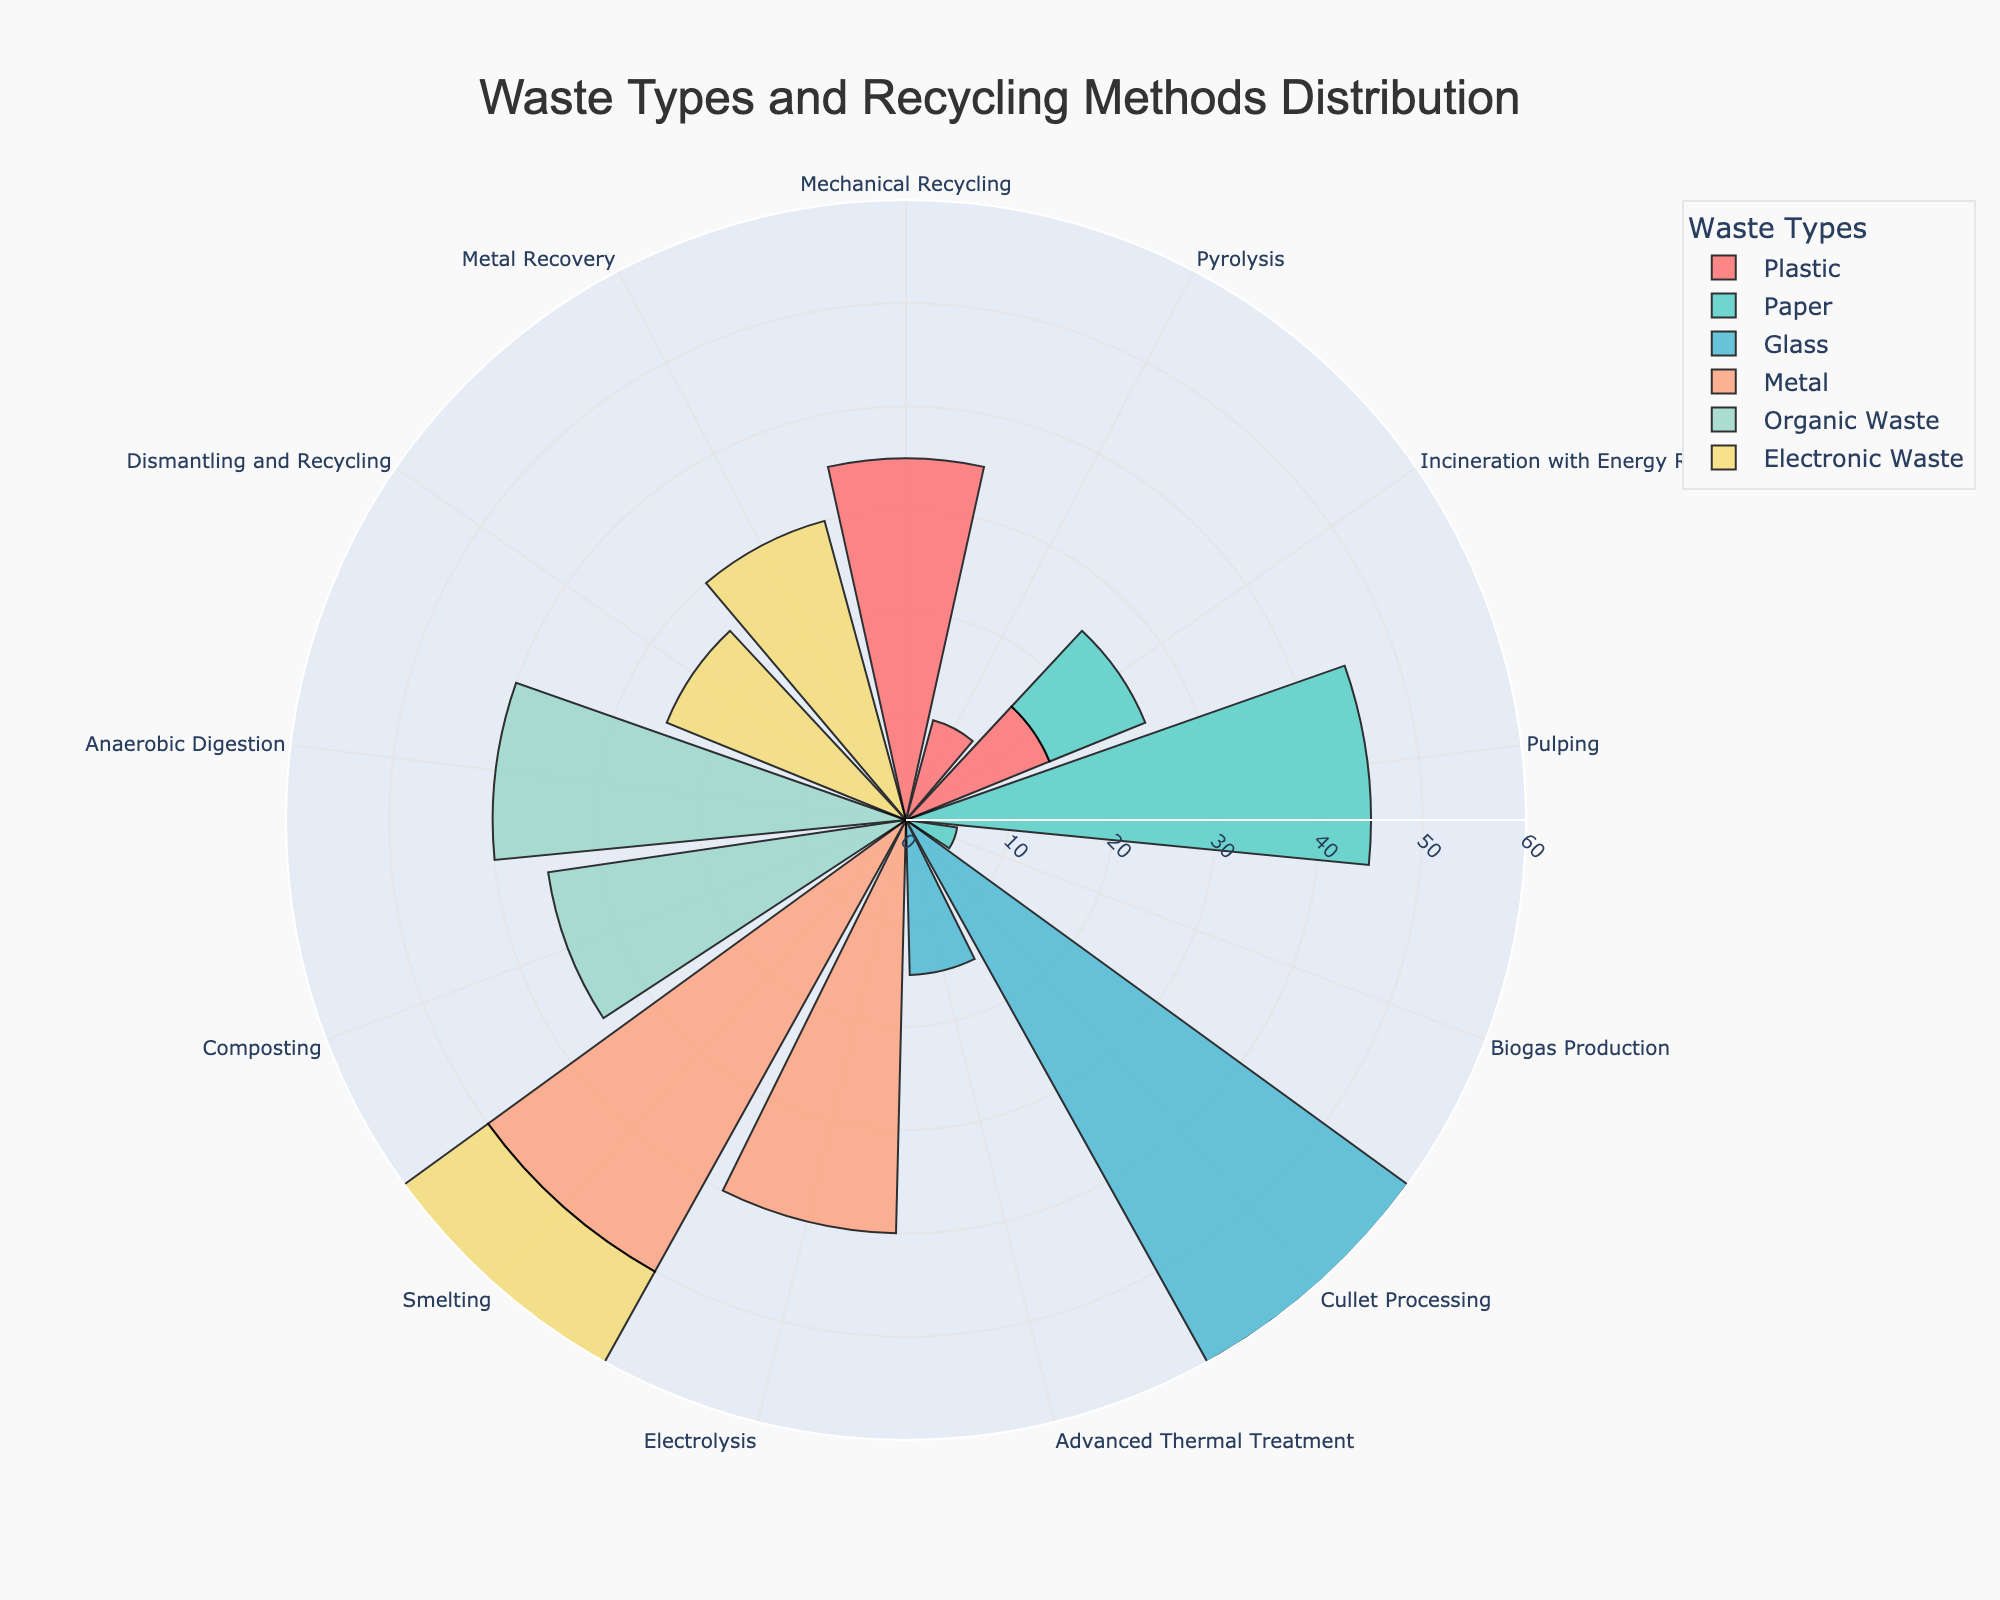What is the title of the figure? The title of the figure is written at the top and describes what the chart represents. From the chart, it reads "Waste Types and Recycling Methods Distribution".
Answer: Waste Types and Recycling Methods Distribution Which recycling method handles the highest percentage of glass? Look at the bars for glass and compare the values. Cullet Processing has the highest value at 60%.
Answer: Cullet Processing What is the combined percentage of plastic processed by Mechanical Recycling and Pyrolysis? Sum the values of Mechanical Recycling and Pyrolysis for plastic. Mechanical Recycling is 35% and Pyrolysis is 10%, so 35 + 10 = 45%.
Answer: 45% What waste type has the most diverse recycling methods in terms of percentage distribution? Examine each waste type's distribution across different methods: Paper has Pulping (45%), Incineration with Energy Recovery (10%), and Biogas Production (5%), showing a wide spread of percentages.
Answer: Paper Which recycling method is used by multiple waste types? Identify recycling methods shared across different waste types. Incineration with Energy Recovery is used by both Plastic and Paper.
Answer: Incineration with Energy Recovery What is the total percentage of waste processed by Smelting? Add the percentages for Smelting across all applicable waste types. Smelting is used for Metal (50%) and Electronic Waste (15%). Thus, 50 + 15 = 65%.
Answer: 65% Compare the percentage of waste processed by Electrolysis for Metal with that by Anaerobic Digestion for Organic Waste. Which one is higher? Look at the percentages for Electrolysis with Metal (40%) and Anaerobic Digestion with Organic Waste (40%). Both percentages are equal.
Answer: Both are equal Which waste type has the smallest maximum percentage across all its recycling methods? Identify the highest percentage for each waste type and compare. Electronic Waste's maximum is 30%, Paper's maximum is 45%, Plastic's maximum is 35%, Metal's maximum is 50%, Organic Waste's maximum is 40%, and Glass's maximum is 60%. Thus, Electronic Waste has the smallest maximum percentage.
Answer: Electronic Waste What is the average percentage of recycling methods for Organic Waste? Calculate the average by adding the percentages for Organic Waste methods and dividing by the number of methods. Composting is 35% and Anaerobic Digestion is 40%. So, (35 + 40) / 2 = 37.5%.
Answer: 37.5% 